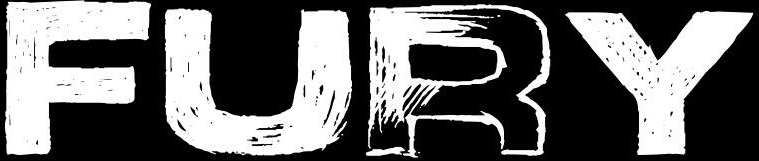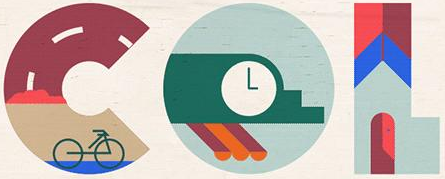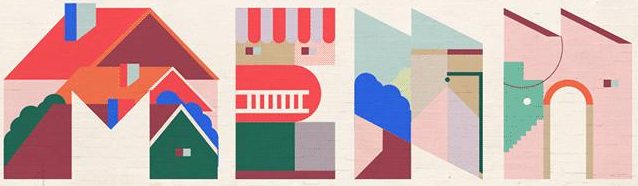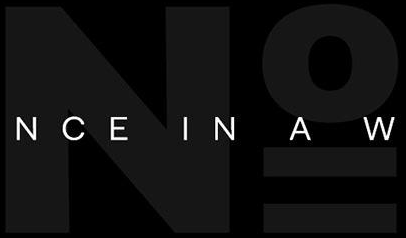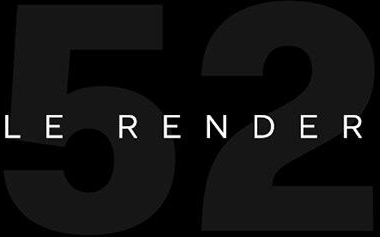What text appears in these images from left to right, separated by a semicolon? FURY; COL; MEAN; No; 52 